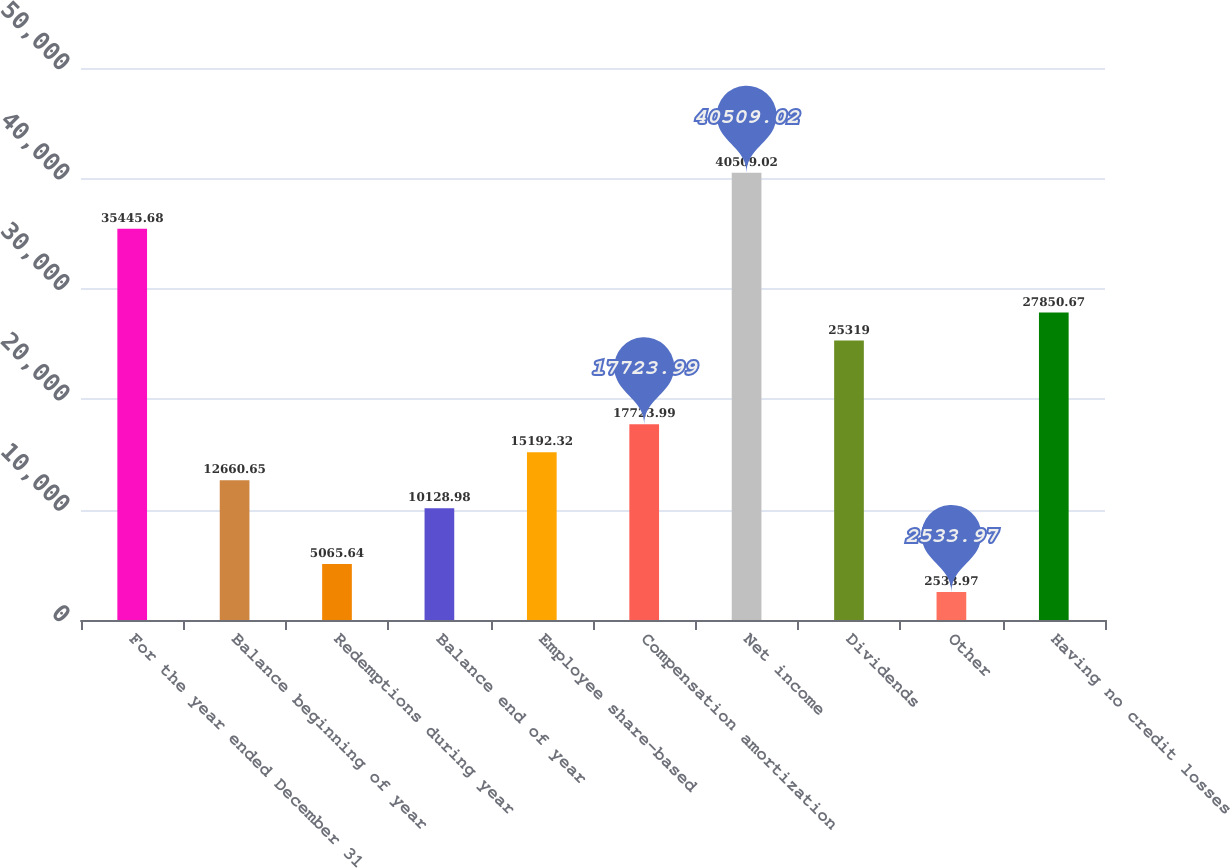Convert chart. <chart><loc_0><loc_0><loc_500><loc_500><bar_chart><fcel>For the year ended December 31<fcel>Balance beginning of year<fcel>Redemptions during year<fcel>Balance end of year<fcel>Employee share-based<fcel>Compensation amortization<fcel>Net income<fcel>Dividends<fcel>Other<fcel>Having no credit losses<nl><fcel>35445.7<fcel>12660.6<fcel>5065.64<fcel>10129<fcel>15192.3<fcel>17724<fcel>40509<fcel>25319<fcel>2533.97<fcel>27850.7<nl></chart> 